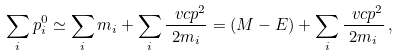Convert formula to latex. <formula><loc_0><loc_0><loc_500><loc_500>\sum _ { i } p _ { i } ^ { 0 } \simeq \sum _ { i } m _ { i } + \sum _ { i } \frac { \ v c { p } ^ { 2 } } { 2 m _ { i } } = ( M - E ) + \sum _ { i } \frac { \ v c { p } ^ { 2 } } { 2 m _ { i } } \, ,</formula> 